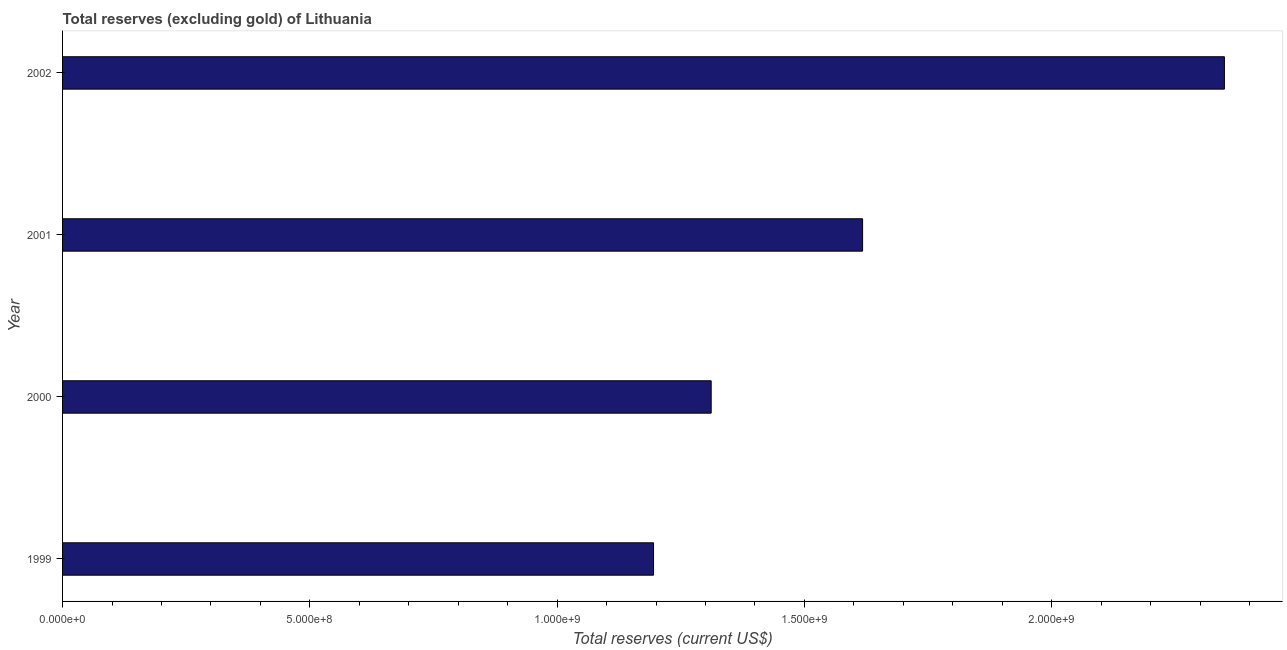What is the title of the graph?
Your response must be concise. Total reserves (excluding gold) of Lithuania. What is the label or title of the X-axis?
Ensure brevity in your answer.  Total reserves (current US$). What is the total reserves (excluding gold) in 2001?
Your answer should be compact. 1.62e+09. Across all years, what is the maximum total reserves (excluding gold)?
Your answer should be compact. 2.35e+09. Across all years, what is the minimum total reserves (excluding gold)?
Give a very brief answer. 1.20e+09. In which year was the total reserves (excluding gold) maximum?
Ensure brevity in your answer.  2002. In which year was the total reserves (excluding gold) minimum?
Your answer should be compact. 1999. What is the sum of the total reserves (excluding gold)?
Ensure brevity in your answer.  6.47e+09. What is the difference between the total reserves (excluding gold) in 2000 and 2002?
Your answer should be compact. -1.04e+09. What is the average total reserves (excluding gold) per year?
Make the answer very short. 1.62e+09. What is the median total reserves (excluding gold)?
Give a very brief answer. 1.46e+09. In how many years, is the total reserves (excluding gold) greater than 1600000000 US$?
Make the answer very short. 2. Do a majority of the years between 2002 and 2000 (inclusive) have total reserves (excluding gold) greater than 700000000 US$?
Ensure brevity in your answer.  Yes. What is the ratio of the total reserves (excluding gold) in 2000 to that in 2001?
Offer a terse response. 0.81. Is the total reserves (excluding gold) in 2000 less than that in 2002?
Make the answer very short. Yes. What is the difference between the highest and the second highest total reserves (excluding gold)?
Your answer should be compact. 7.32e+08. What is the difference between the highest and the lowest total reserves (excluding gold)?
Keep it short and to the point. 1.15e+09. Are all the bars in the graph horizontal?
Ensure brevity in your answer.  Yes. What is the difference between two consecutive major ticks on the X-axis?
Your answer should be compact. 5.00e+08. Are the values on the major ticks of X-axis written in scientific E-notation?
Your answer should be compact. Yes. What is the Total reserves (current US$) in 1999?
Your response must be concise. 1.20e+09. What is the Total reserves (current US$) in 2000?
Ensure brevity in your answer.  1.31e+09. What is the Total reserves (current US$) in 2001?
Ensure brevity in your answer.  1.62e+09. What is the Total reserves (current US$) in 2002?
Provide a succinct answer. 2.35e+09. What is the difference between the Total reserves (current US$) in 1999 and 2000?
Your answer should be compact. -1.17e+08. What is the difference between the Total reserves (current US$) in 1999 and 2001?
Make the answer very short. -4.23e+08. What is the difference between the Total reserves (current US$) in 1999 and 2002?
Your answer should be compact. -1.15e+09. What is the difference between the Total reserves (current US$) in 2000 and 2001?
Give a very brief answer. -3.06e+08. What is the difference between the Total reserves (current US$) in 2000 and 2002?
Your response must be concise. -1.04e+09. What is the difference between the Total reserves (current US$) in 2001 and 2002?
Your answer should be compact. -7.32e+08. What is the ratio of the Total reserves (current US$) in 1999 to that in 2000?
Ensure brevity in your answer.  0.91. What is the ratio of the Total reserves (current US$) in 1999 to that in 2001?
Give a very brief answer. 0.74. What is the ratio of the Total reserves (current US$) in 1999 to that in 2002?
Ensure brevity in your answer.  0.51. What is the ratio of the Total reserves (current US$) in 2000 to that in 2001?
Your response must be concise. 0.81. What is the ratio of the Total reserves (current US$) in 2000 to that in 2002?
Your answer should be compact. 0.56. What is the ratio of the Total reserves (current US$) in 2001 to that in 2002?
Provide a short and direct response. 0.69. 